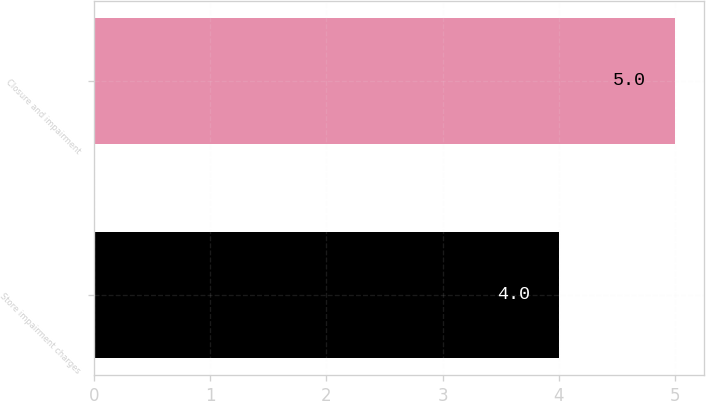Convert chart to OTSL. <chart><loc_0><loc_0><loc_500><loc_500><bar_chart><fcel>Store impairment charges<fcel>Closure and impairment<nl><fcel>4<fcel>5<nl></chart> 